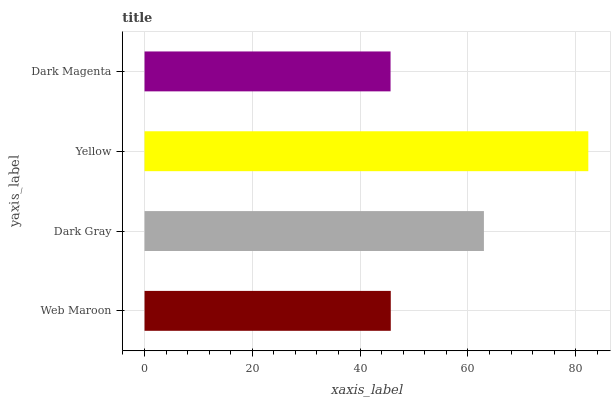Is Dark Magenta the minimum?
Answer yes or no. Yes. Is Yellow the maximum?
Answer yes or no. Yes. Is Dark Gray the minimum?
Answer yes or no. No. Is Dark Gray the maximum?
Answer yes or no. No. Is Dark Gray greater than Web Maroon?
Answer yes or no. Yes. Is Web Maroon less than Dark Gray?
Answer yes or no. Yes. Is Web Maroon greater than Dark Gray?
Answer yes or no. No. Is Dark Gray less than Web Maroon?
Answer yes or no. No. Is Dark Gray the high median?
Answer yes or no. Yes. Is Web Maroon the low median?
Answer yes or no. Yes. Is Web Maroon the high median?
Answer yes or no. No. Is Yellow the low median?
Answer yes or no. No. 